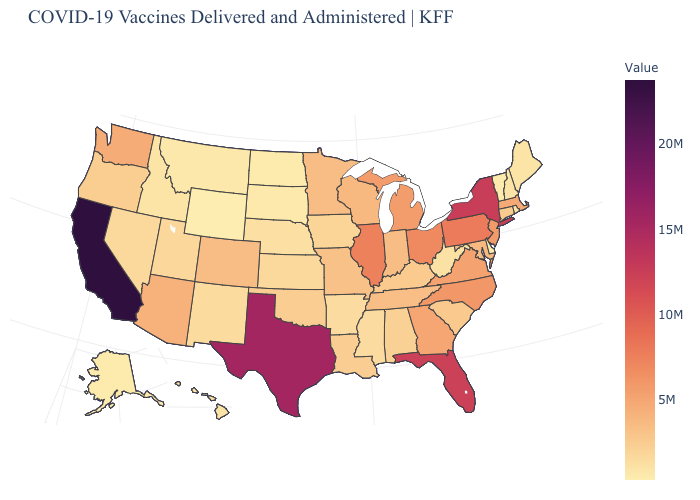Among the states that border Wyoming , does South Dakota have the highest value?
Short answer required. No. Does California have the highest value in the USA?
Concise answer only. Yes. Among the states that border Texas , which have the lowest value?
Give a very brief answer. Arkansas. Which states have the lowest value in the South?
Concise answer only. Delaware. Does the map have missing data?
Keep it brief. No. 